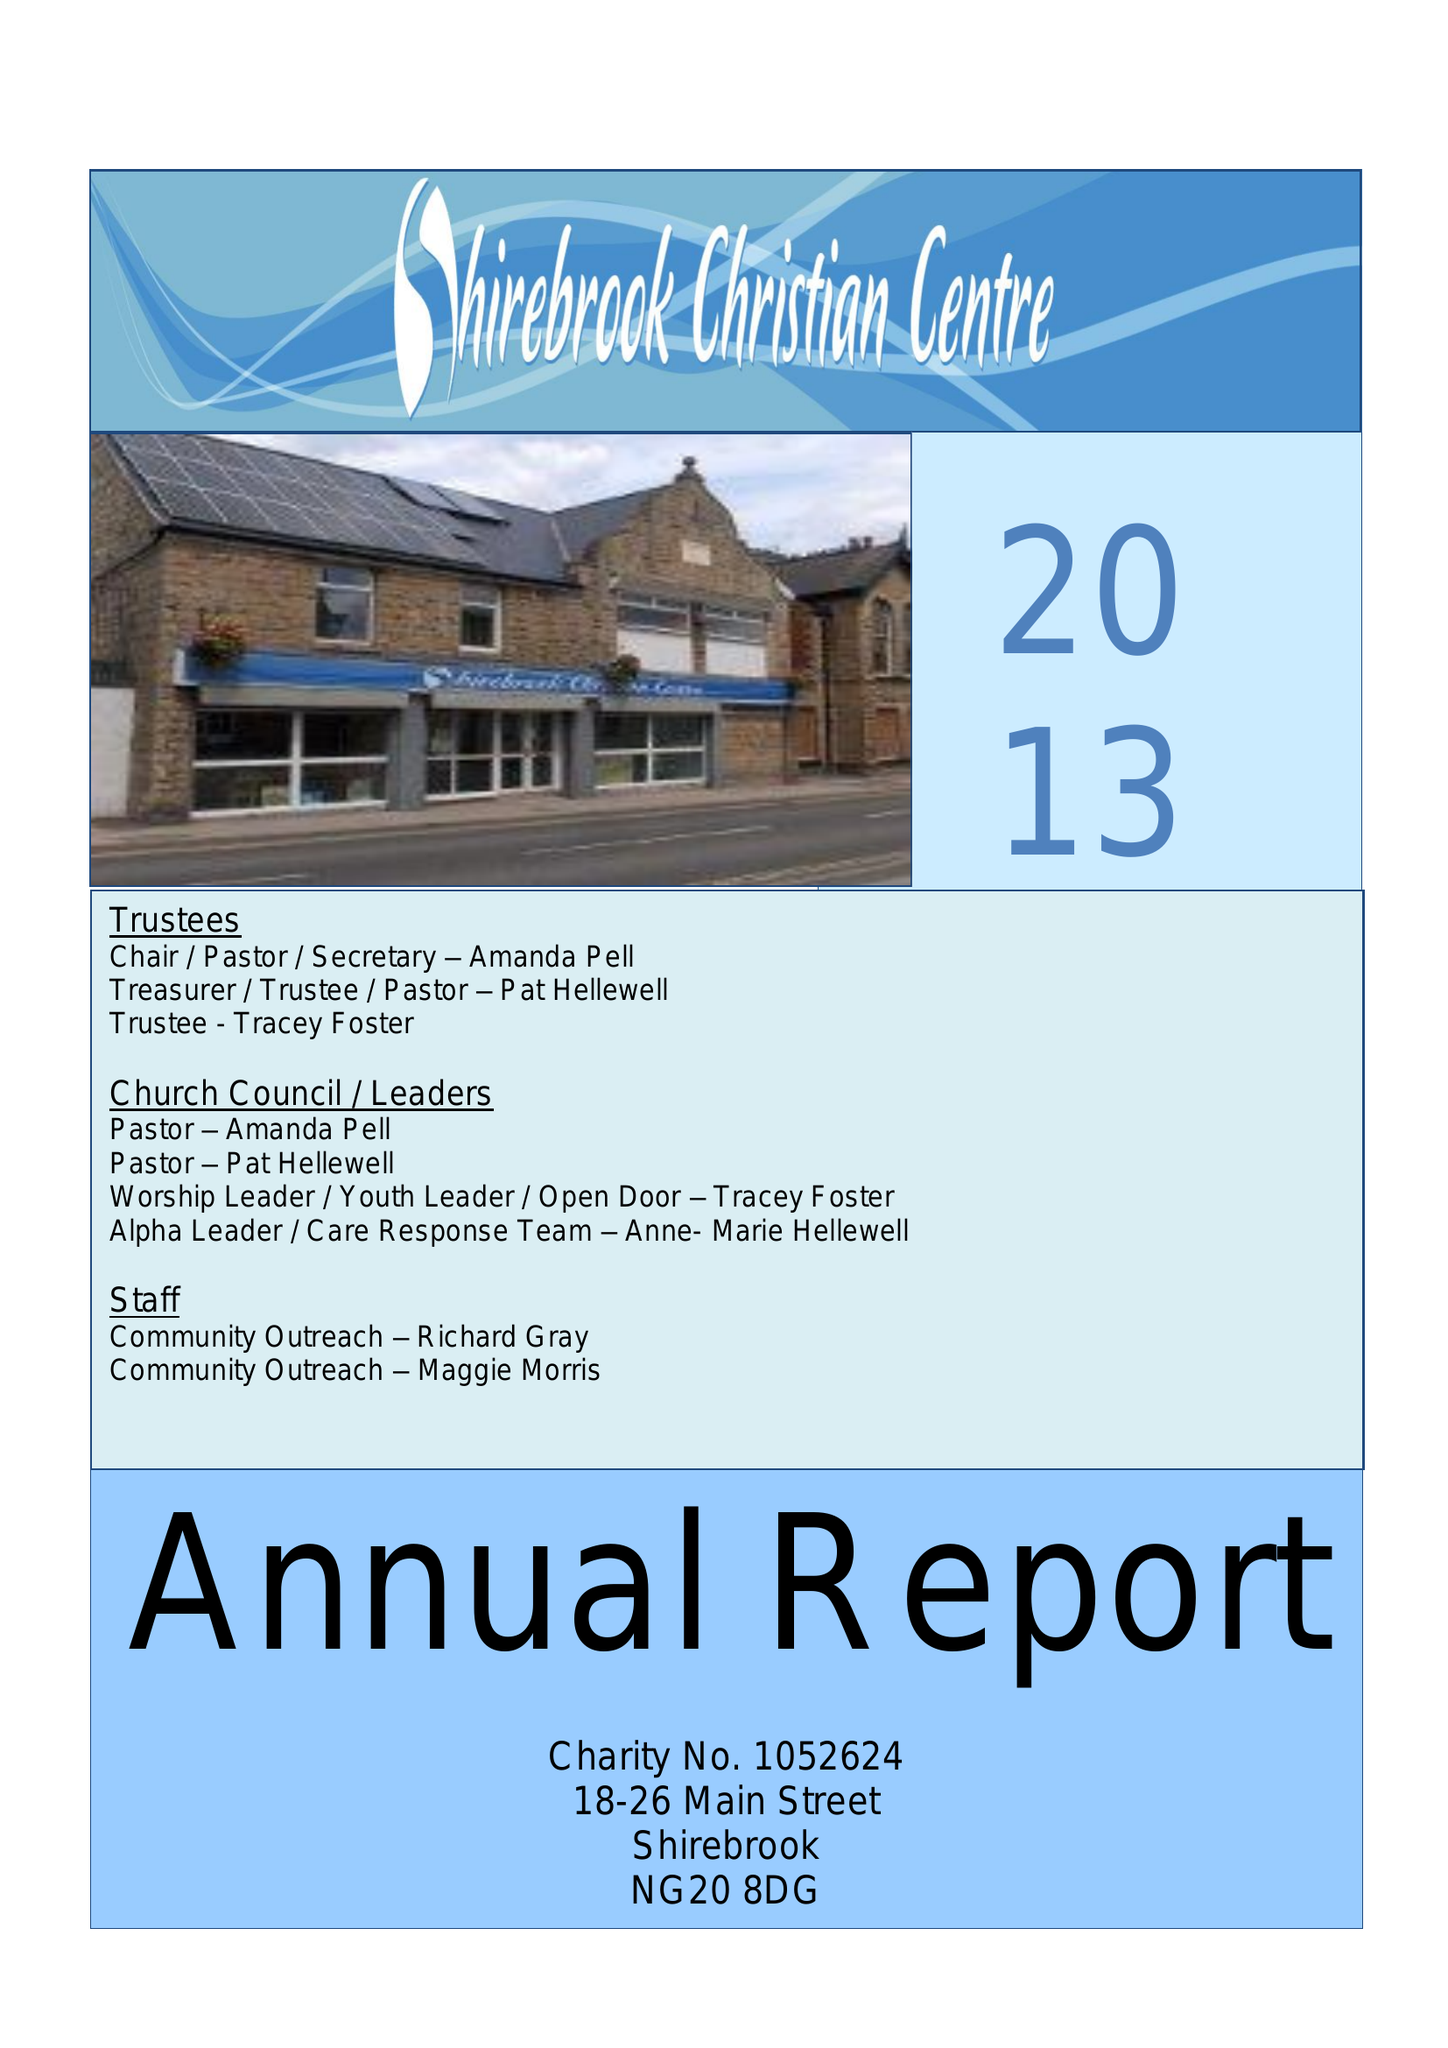What is the value for the address__postcode?
Answer the question using a single word or phrase. NG20 8DG 